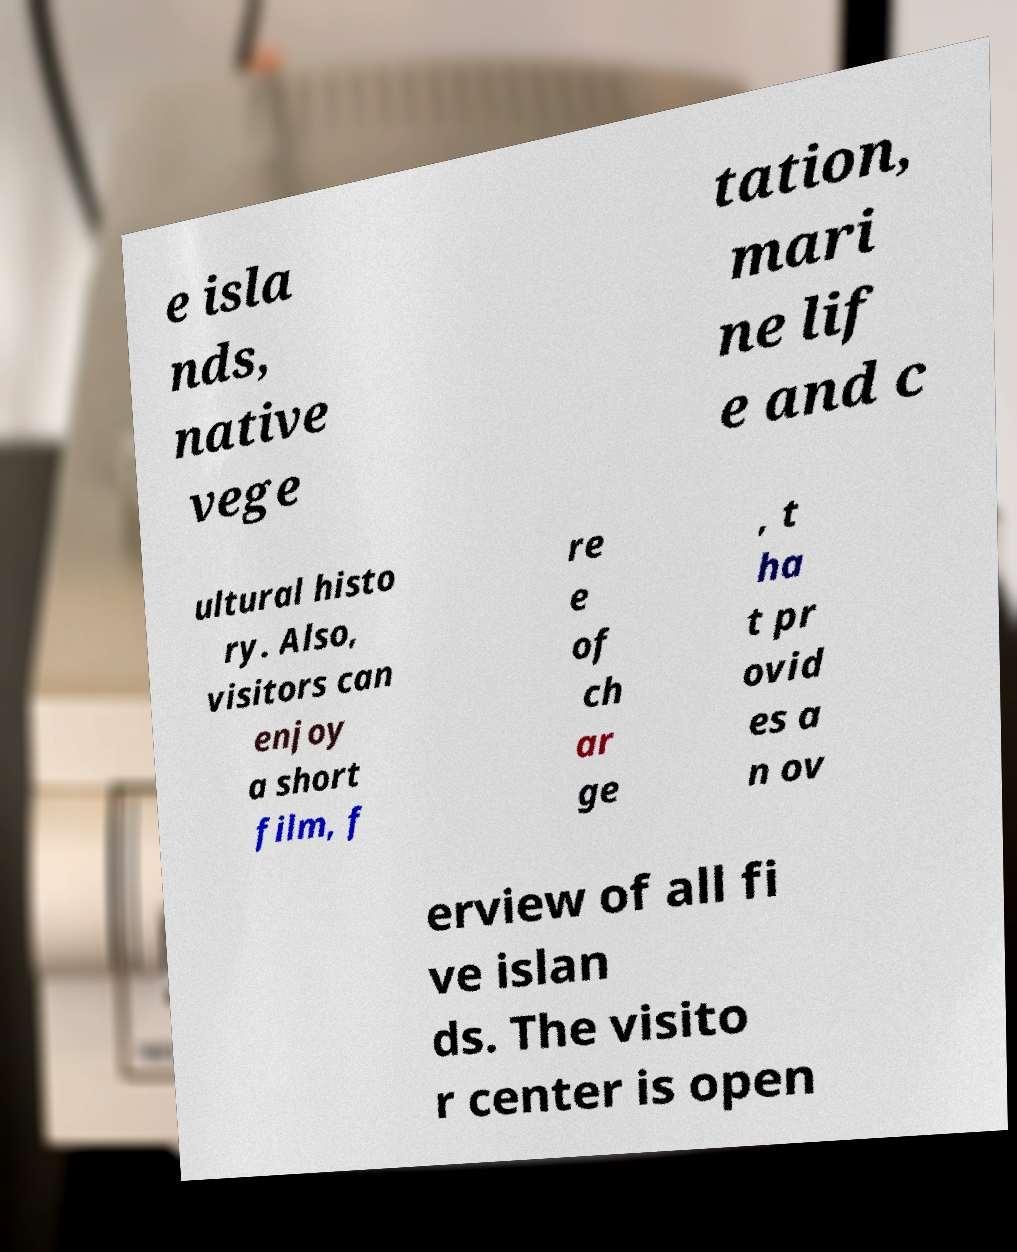Please read and relay the text visible in this image. What does it say? e isla nds, native vege tation, mari ne lif e and c ultural histo ry. Also, visitors can enjoy a short film, f re e of ch ar ge , t ha t pr ovid es a n ov erview of all fi ve islan ds. The visito r center is open 